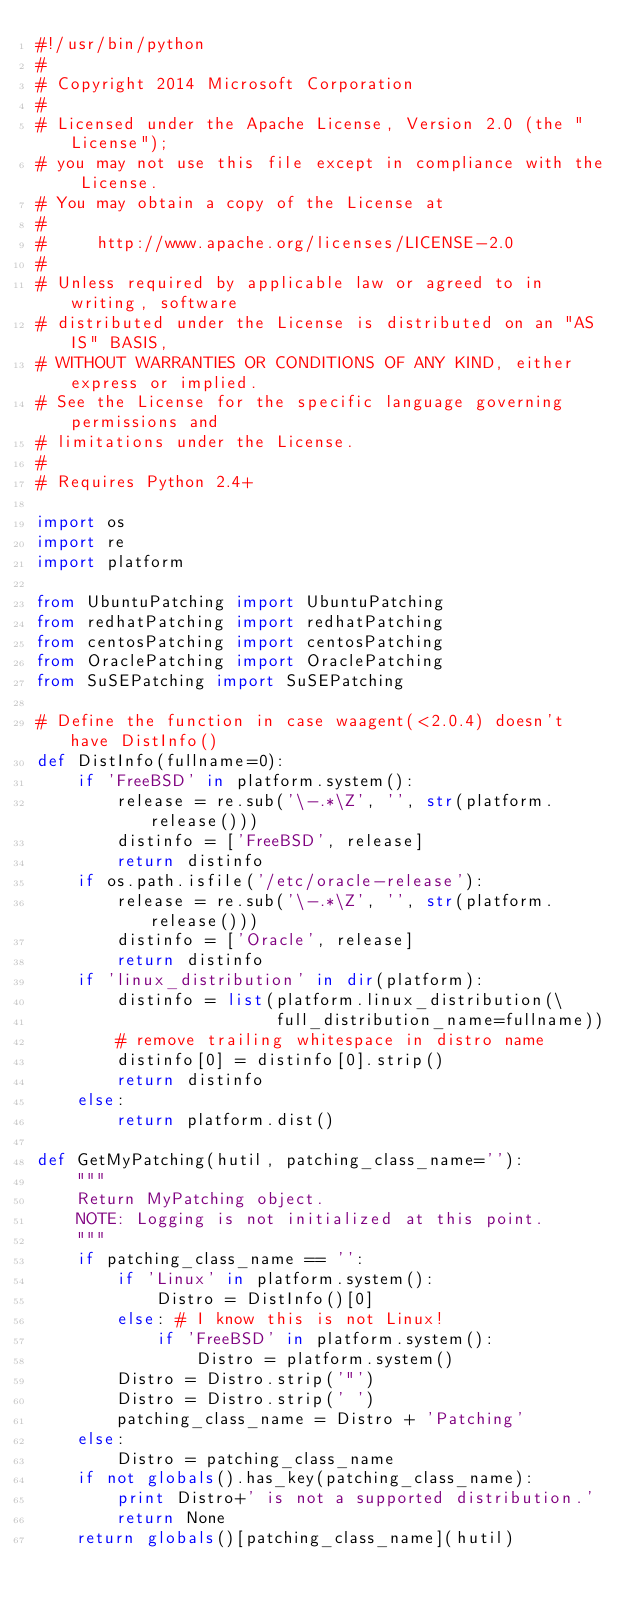<code> <loc_0><loc_0><loc_500><loc_500><_Python_>#!/usr/bin/python
#
# Copyright 2014 Microsoft Corporation
#
# Licensed under the Apache License, Version 2.0 (the "License");
# you may not use this file except in compliance with the License.
# You may obtain a copy of the License at
#
#     http://www.apache.org/licenses/LICENSE-2.0
#
# Unless required by applicable law or agreed to in writing, software
# distributed under the License is distributed on an "AS IS" BASIS,
# WITHOUT WARRANTIES OR CONDITIONS OF ANY KIND, either express or implied.
# See the License for the specific language governing permissions and
# limitations under the License.
#
# Requires Python 2.4+

import os
import re
import platform

from UbuntuPatching import UbuntuPatching
from redhatPatching import redhatPatching
from centosPatching import centosPatching
from OraclePatching import OraclePatching
from SuSEPatching import SuSEPatching

# Define the function in case waagent(<2.0.4) doesn't have DistInfo()
def DistInfo(fullname=0):
    if 'FreeBSD' in platform.system():
        release = re.sub('\-.*\Z', '', str(platform.release()))
        distinfo = ['FreeBSD', release]
        return distinfo
    if os.path.isfile('/etc/oracle-release'):
        release = re.sub('\-.*\Z', '', str(platform.release()))
        distinfo = ['Oracle', release]
        return distinfo
    if 'linux_distribution' in dir(platform):
        distinfo = list(platform.linux_distribution(\
                        full_distribution_name=fullname))
        # remove trailing whitespace in distro name
        distinfo[0] = distinfo[0].strip()
        return distinfo
    else:
        return platform.dist()

def GetMyPatching(hutil, patching_class_name=''):
    """
    Return MyPatching object.
    NOTE: Logging is not initialized at this point.
    """
    if patching_class_name == '':
        if 'Linux' in platform.system():
            Distro = DistInfo()[0]
        else: # I know this is not Linux!
            if 'FreeBSD' in platform.system():
                Distro = platform.system()
        Distro = Distro.strip('"')
        Distro = Distro.strip(' ')
        patching_class_name = Distro + 'Patching'
    else:
        Distro = patching_class_name
    if not globals().has_key(patching_class_name):
        print Distro+' is not a supported distribution.'
        return None
    return globals()[patching_class_name](hutil)
</code> 